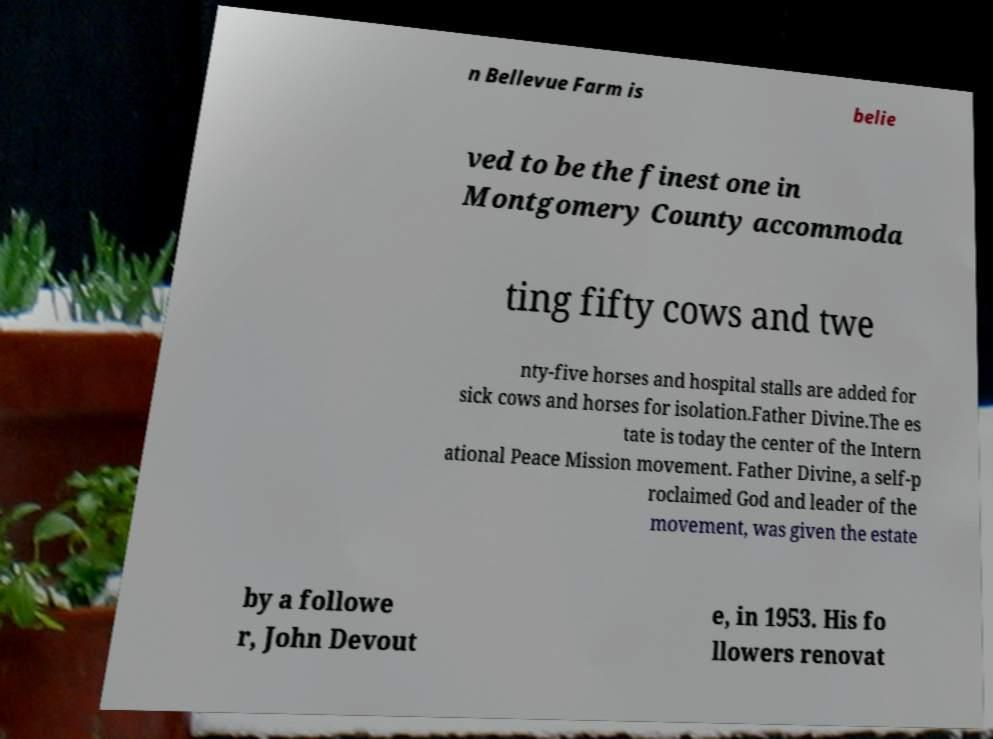Could you assist in decoding the text presented in this image and type it out clearly? n Bellevue Farm is belie ved to be the finest one in Montgomery County accommoda ting fifty cows and twe nty-five horses and hospital stalls are added for sick cows and horses for isolation.Father Divine.The es tate is today the center of the Intern ational Peace Mission movement. Father Divine, a self-p roclaimed God and leader of the movement, was given the estate by a followe r, John Devout e, in 1953. His fo llowers renovat 